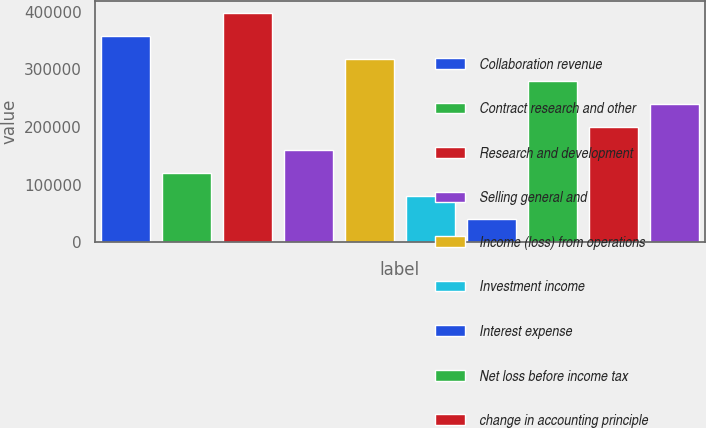<chart> <loc_0><loc_0><loc_500><loc_500><bar_chart><fcel>Collaboration revenue<fcel>Contract research and other<fcel>Research and development<fcel>Selling general and<fcel>Income (loss) from operations<fcel>Investment income<fcel>Interest expense<fcel>Net loss before income tax<fcel>change in accounting principle<fcel>Net loss<nl><fcel>358886<fcel>119629<fcel>398762<fcel>159505<fcel>319010<fcel>79753.1<fcel>39877<fcel>279134<fcel>199381<fcel>239258<nl></chart> 